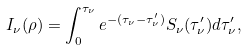<formula> <loc_0><loc_0><loc_500><loc_500>I _ { \nu } ( \rho ) = \int _ { 0 } ^ { \tau _ { \nu } } e ^ { - ( \tau _ { \nu } - \tau ^ { \prime } _ { \nu } ) } S _ { \nu } ( \tau ^ { \prime } _ { \nu } ) d \tau ^ { \prime } _ { \nu } ,</formula> 